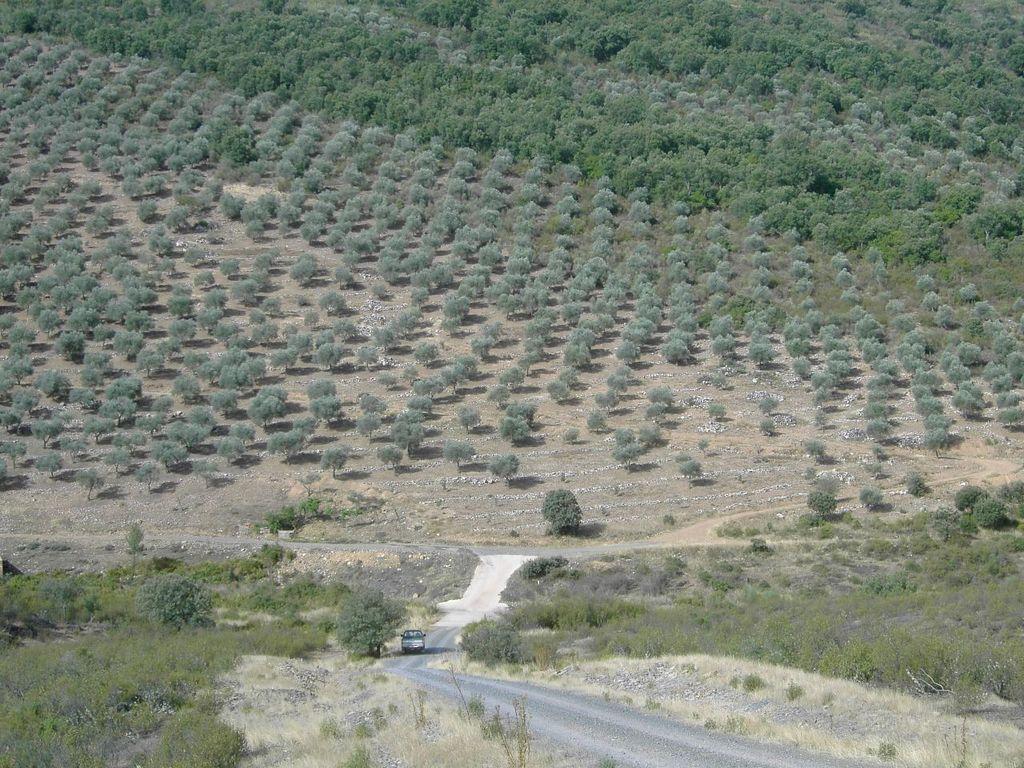Can you describe this image briefly? In the picture I can see vehicle is moving on the road, side we can see so many trees. 